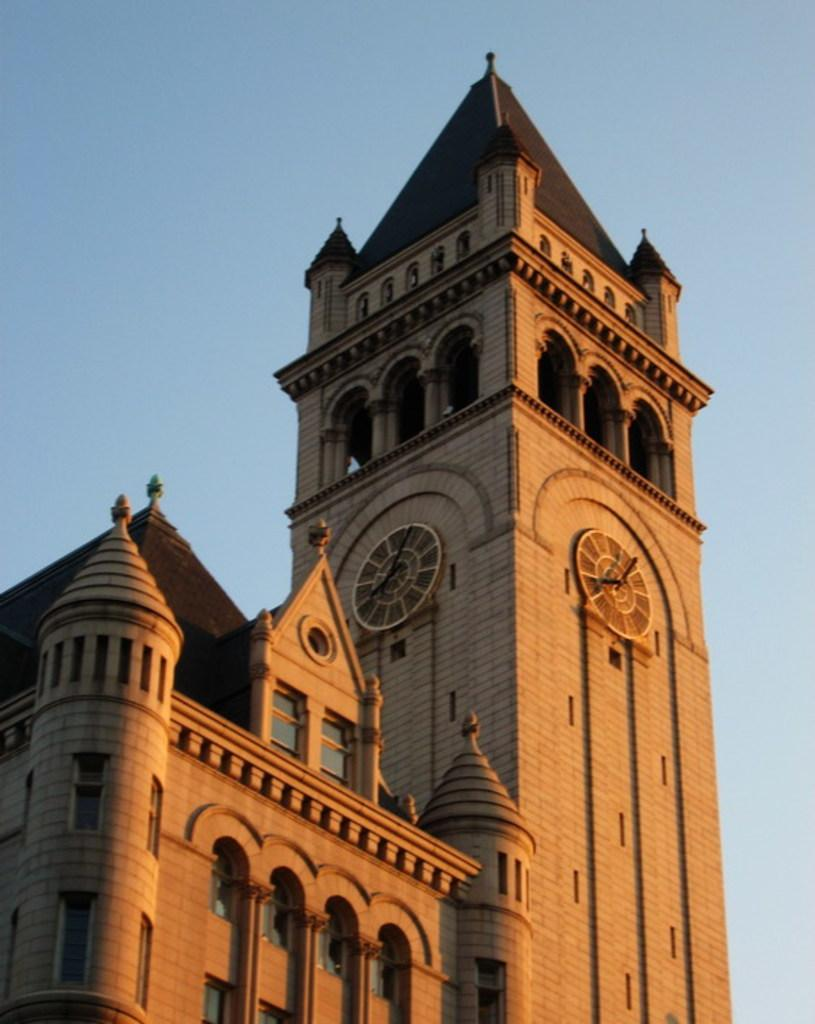What type of structures can be seen in the image? There are buildings in the image. What part of the natural environment is visible in the image? The sky is visible in the image. What type of mint can be seen growing near the buildings in the image? There is no mint present in the image; it only features buildings and the sky. 